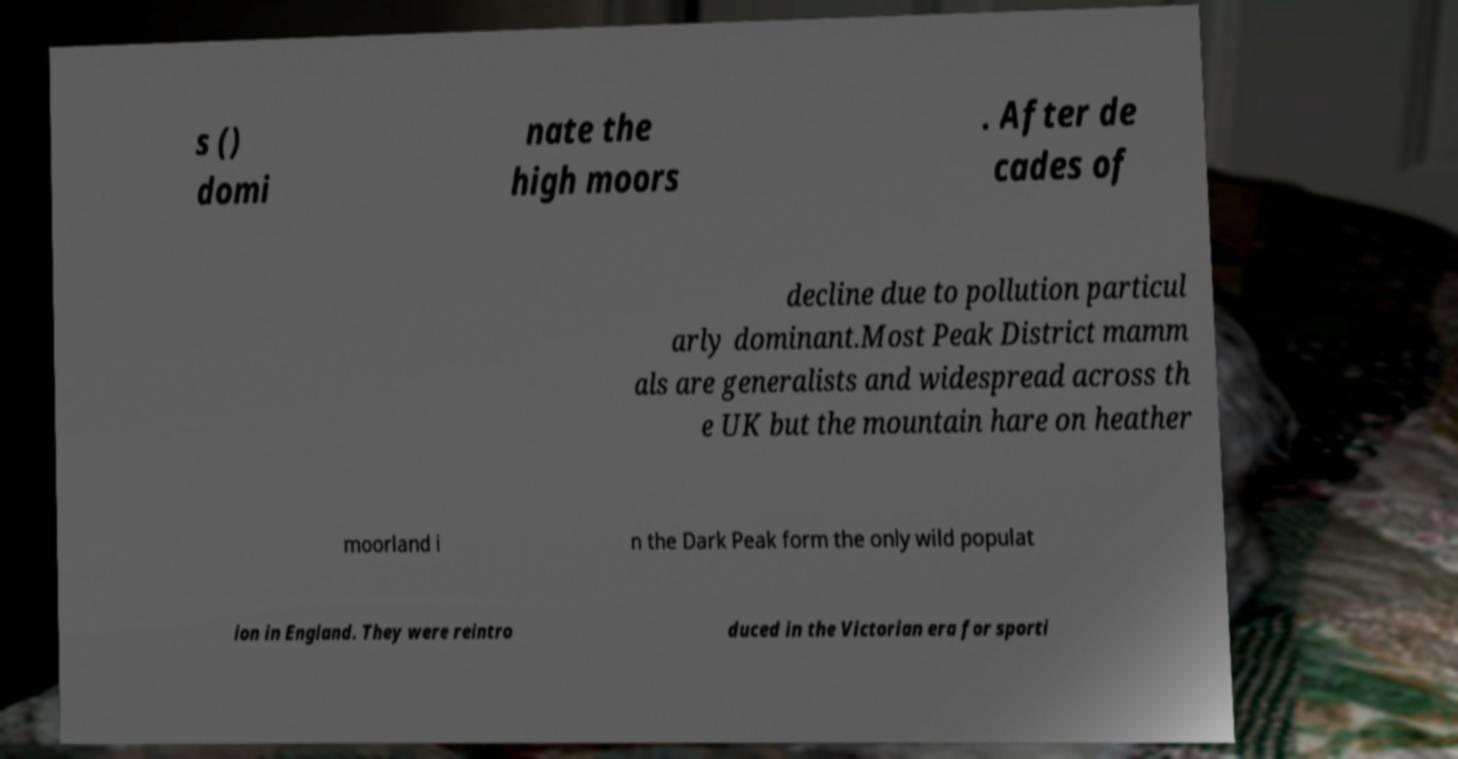Please identify and transcribe the text found in this image. s () domi nate the high moors . After de cades of decline due to pollution particul arly dominant.Most Peak District mamm als are generalists and widespread across th e UK but the mountain hare on heather moorland i n the Dark Peak form the only wild populat ion in England. They were reintro duced in the Victorian era for sporti 